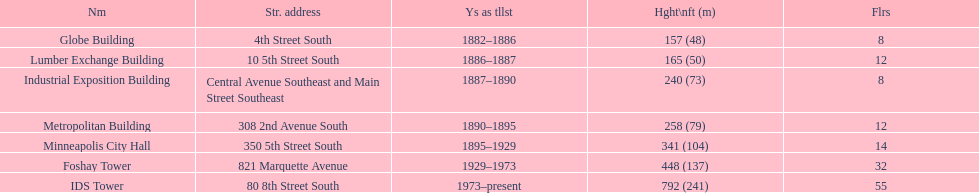Which building has 8 floors and is 240 ft tall? Industrial Exposition Building. 